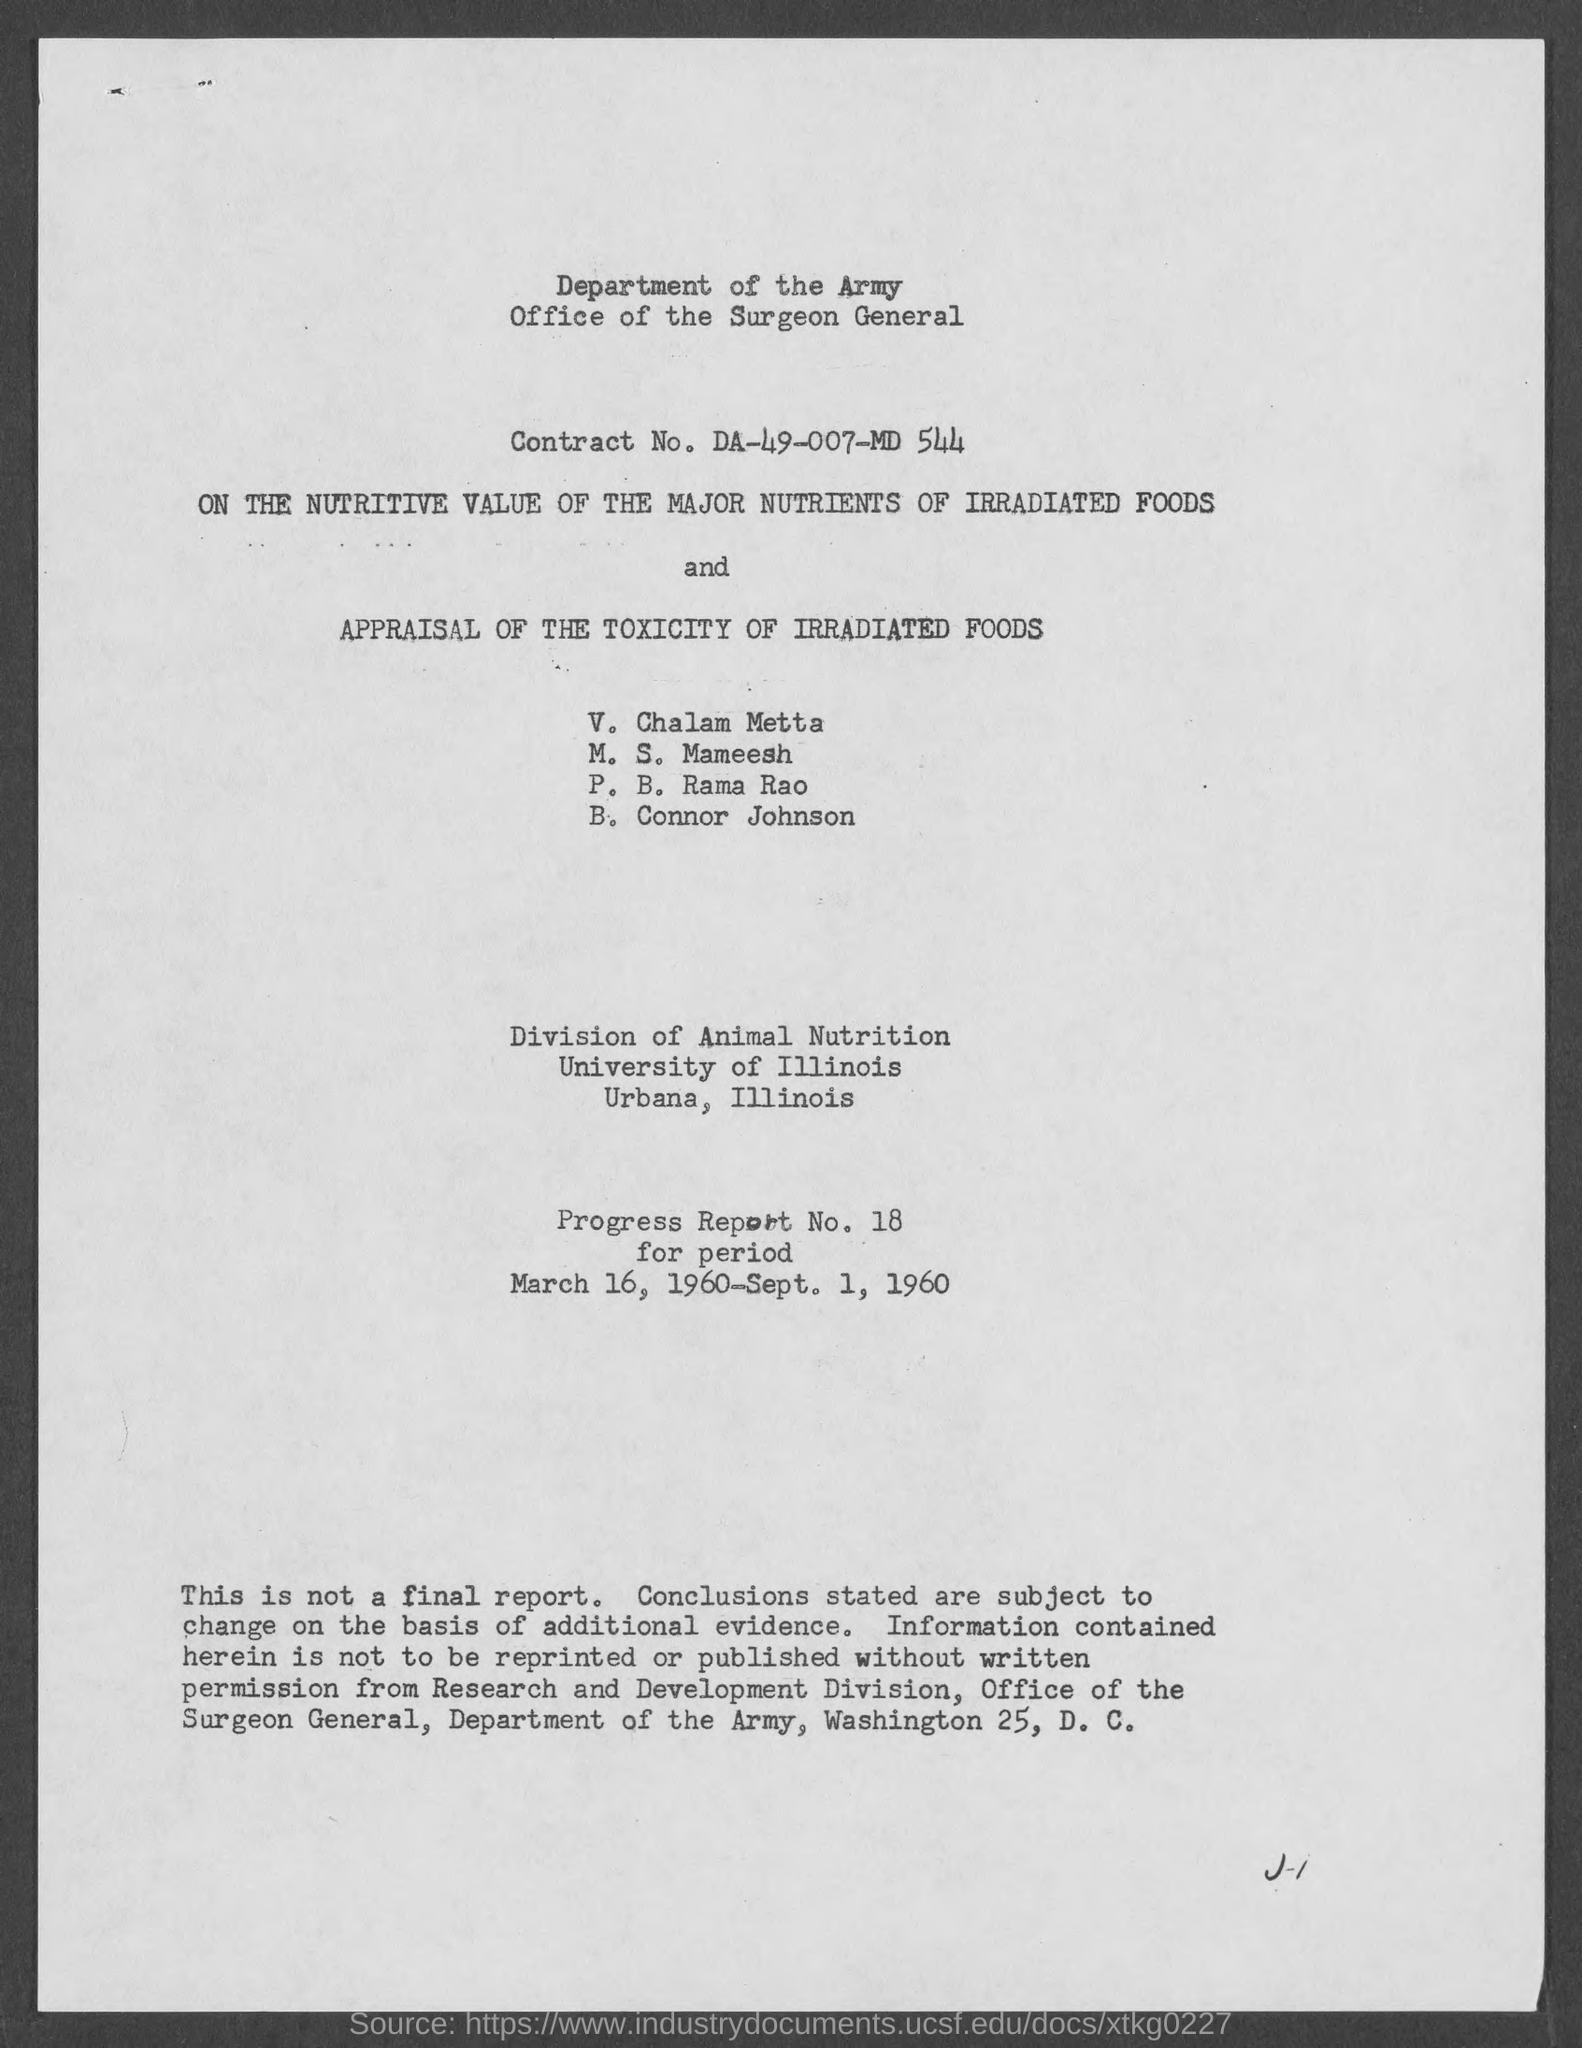Outline some significant characteristics in this image. The progress report number is Progress Report No. 18. The period covered in the progress report is from March 16, 1960, to September 1, 1960. The contract number is DA-49-007-MD-544. 